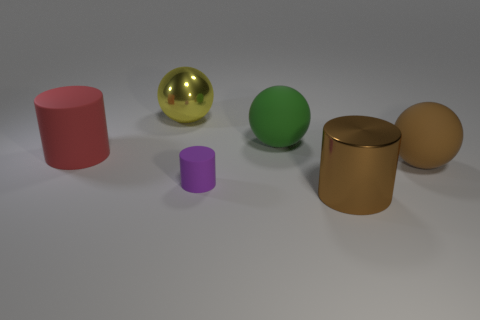What objects are closest to the green sphere? The green sphere is flanked by two objects - a shiny gold cylinder on its left and a smaller purple cylinder on its right. These two are the closest objects to the green sphere.  Can you describe the textures of the objects in the scene? Certainly! The objects exhibit a variety of textures. The pink and gold cylinders, as well as the green and purple spheres, have a matte finish, which diffuses light gently. On the other hand, the yellow sphere has a highly reflective, mirror-like surface, which clearly reflects the surrounding environment. 